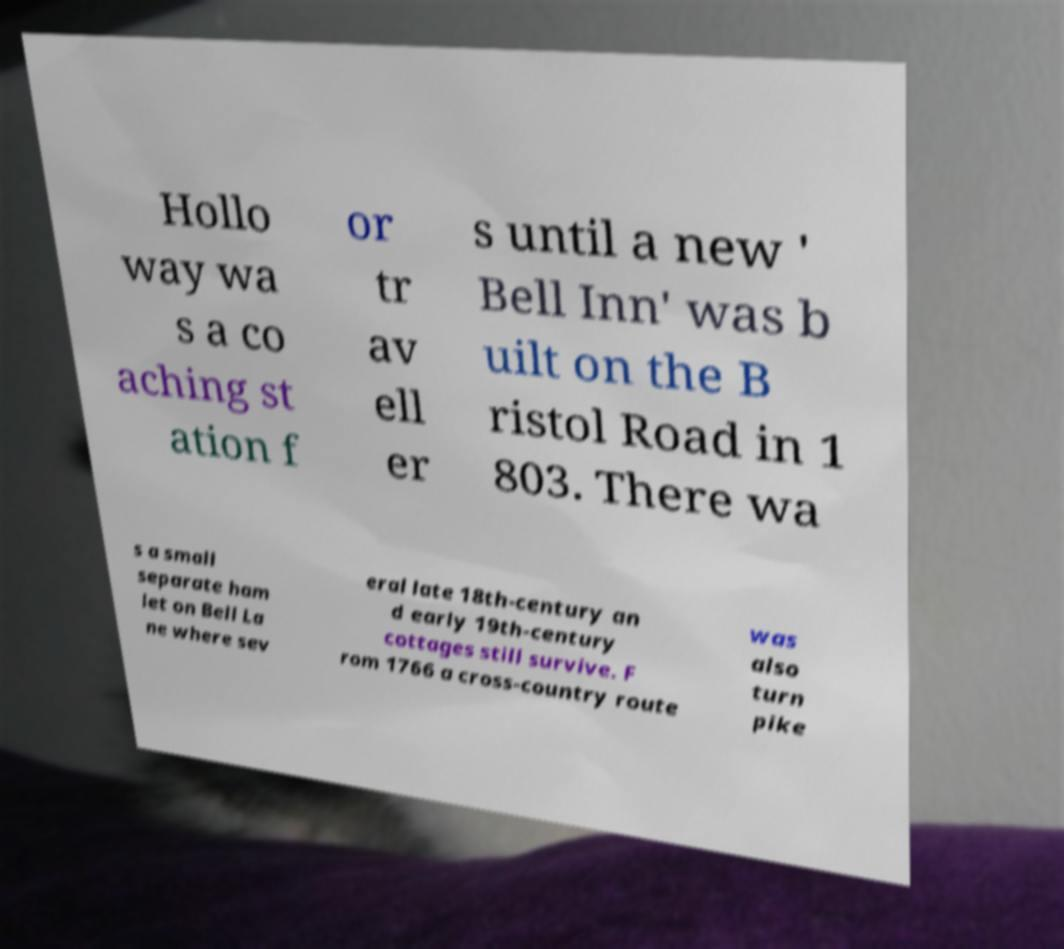Please identify and transcribe the text found in this image. Hollo way wa s a co aching st ation f or tr av ell er s until a new ' Bell Inn' was b uilt on the B ristol Road in 1 803. There wa s a small separate ham let on Bell La ne where sev eral late 18th-century an d early 19th-century cottages still survive. F rom 1766 a cross-country route was also turn pike 